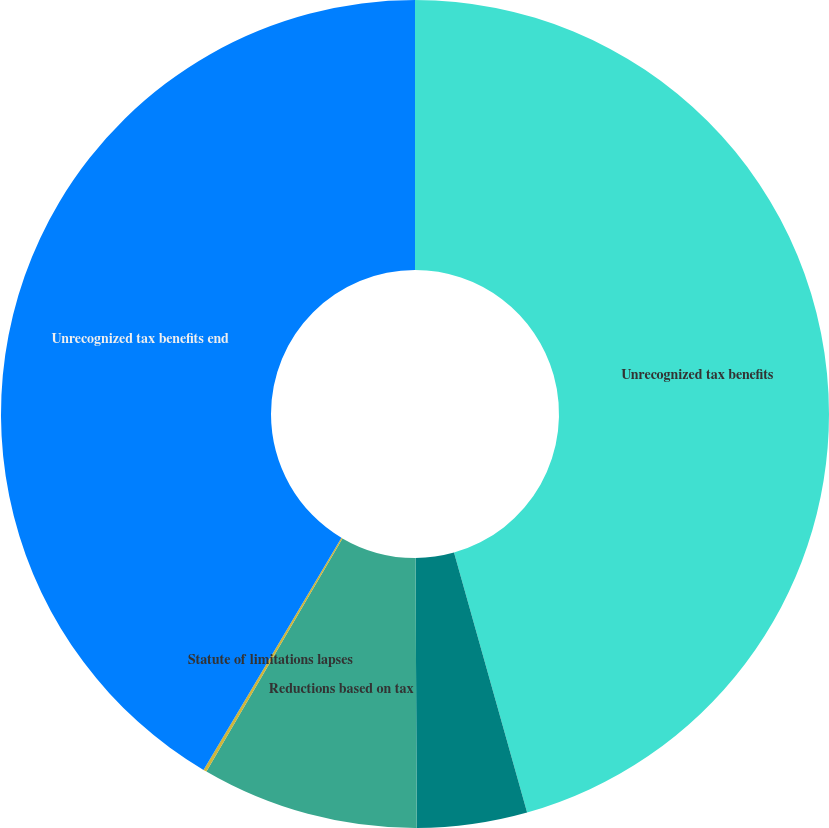Convert chart to OTSL. <chart><loc_0><loc_0><loc_500><loc_500><pie_chart><fcel>Unrecognized tax benefits<fcel>Additions based on tax<fcel>Reductions based on tax<fcel>Statute of limitations lapses<fcel>Unrecognized tax benefits end<nl><fcel>45.64%<fcel>4.3%<fcel>8.47%<fcel>0.13%<fcel>41.47%<nl></chart> 